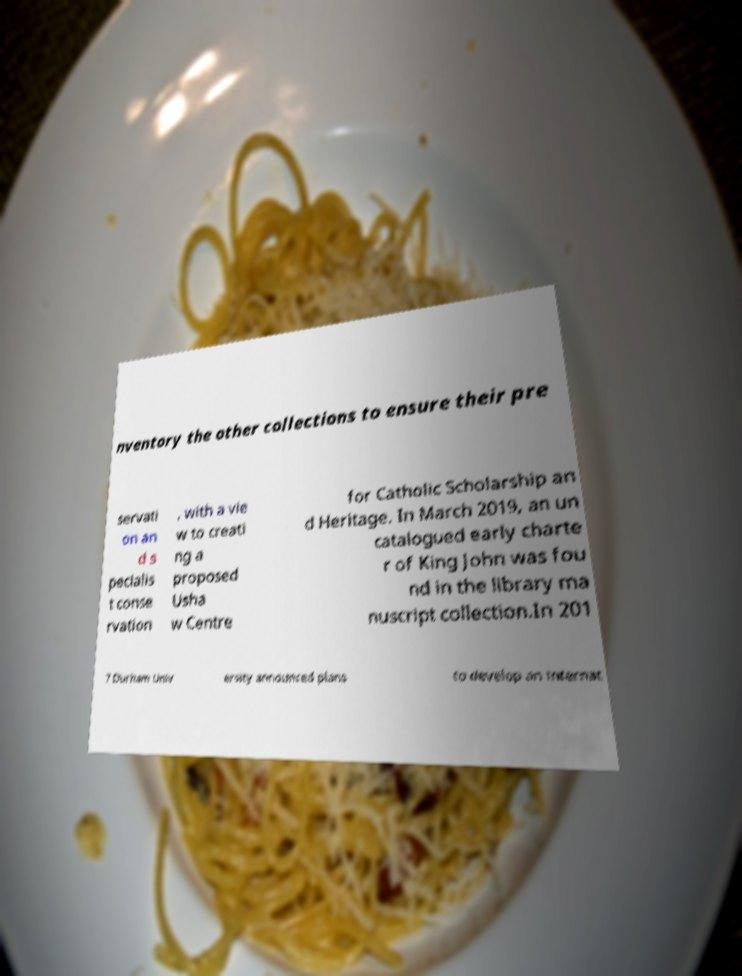For documentation purposes, I need the text within this image transcribed. Could you provide that? nventory the other collections to ensure their pre servati on an d s pecialis t conse rvation , with a vie w to creati ng a proposed Usha w Centre for Catholic Scholarship an d Heritage. In March 2019, an un catalogued early charte r of King John was fou nd in the library ma nuscript collection.In 201 7 Durham Univ ersity announced plans to develop an internat 